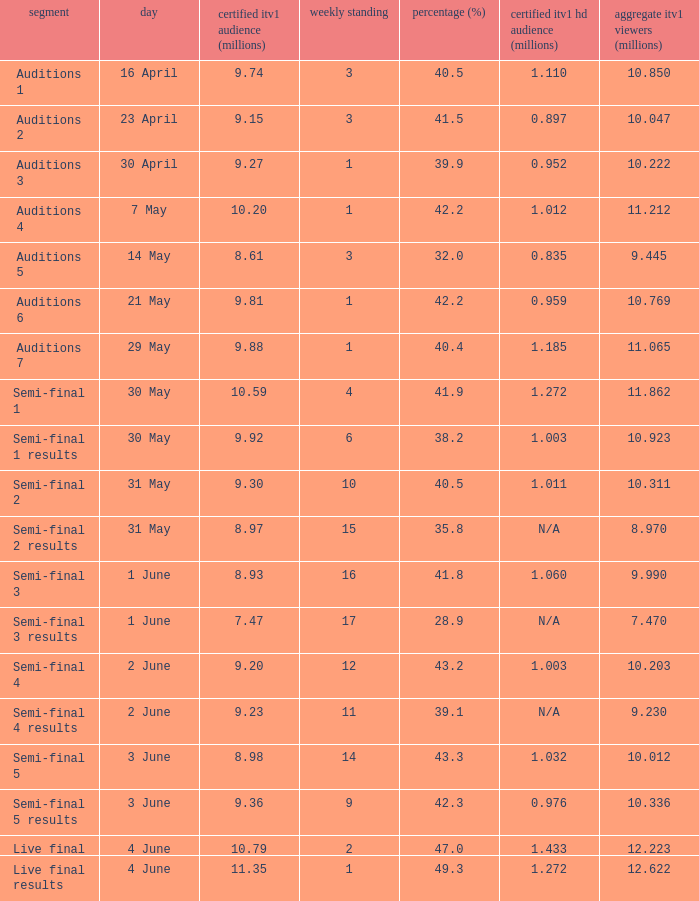Which episode had an official ITV1 HD rating of 1.185 million?  Auditions 7. 